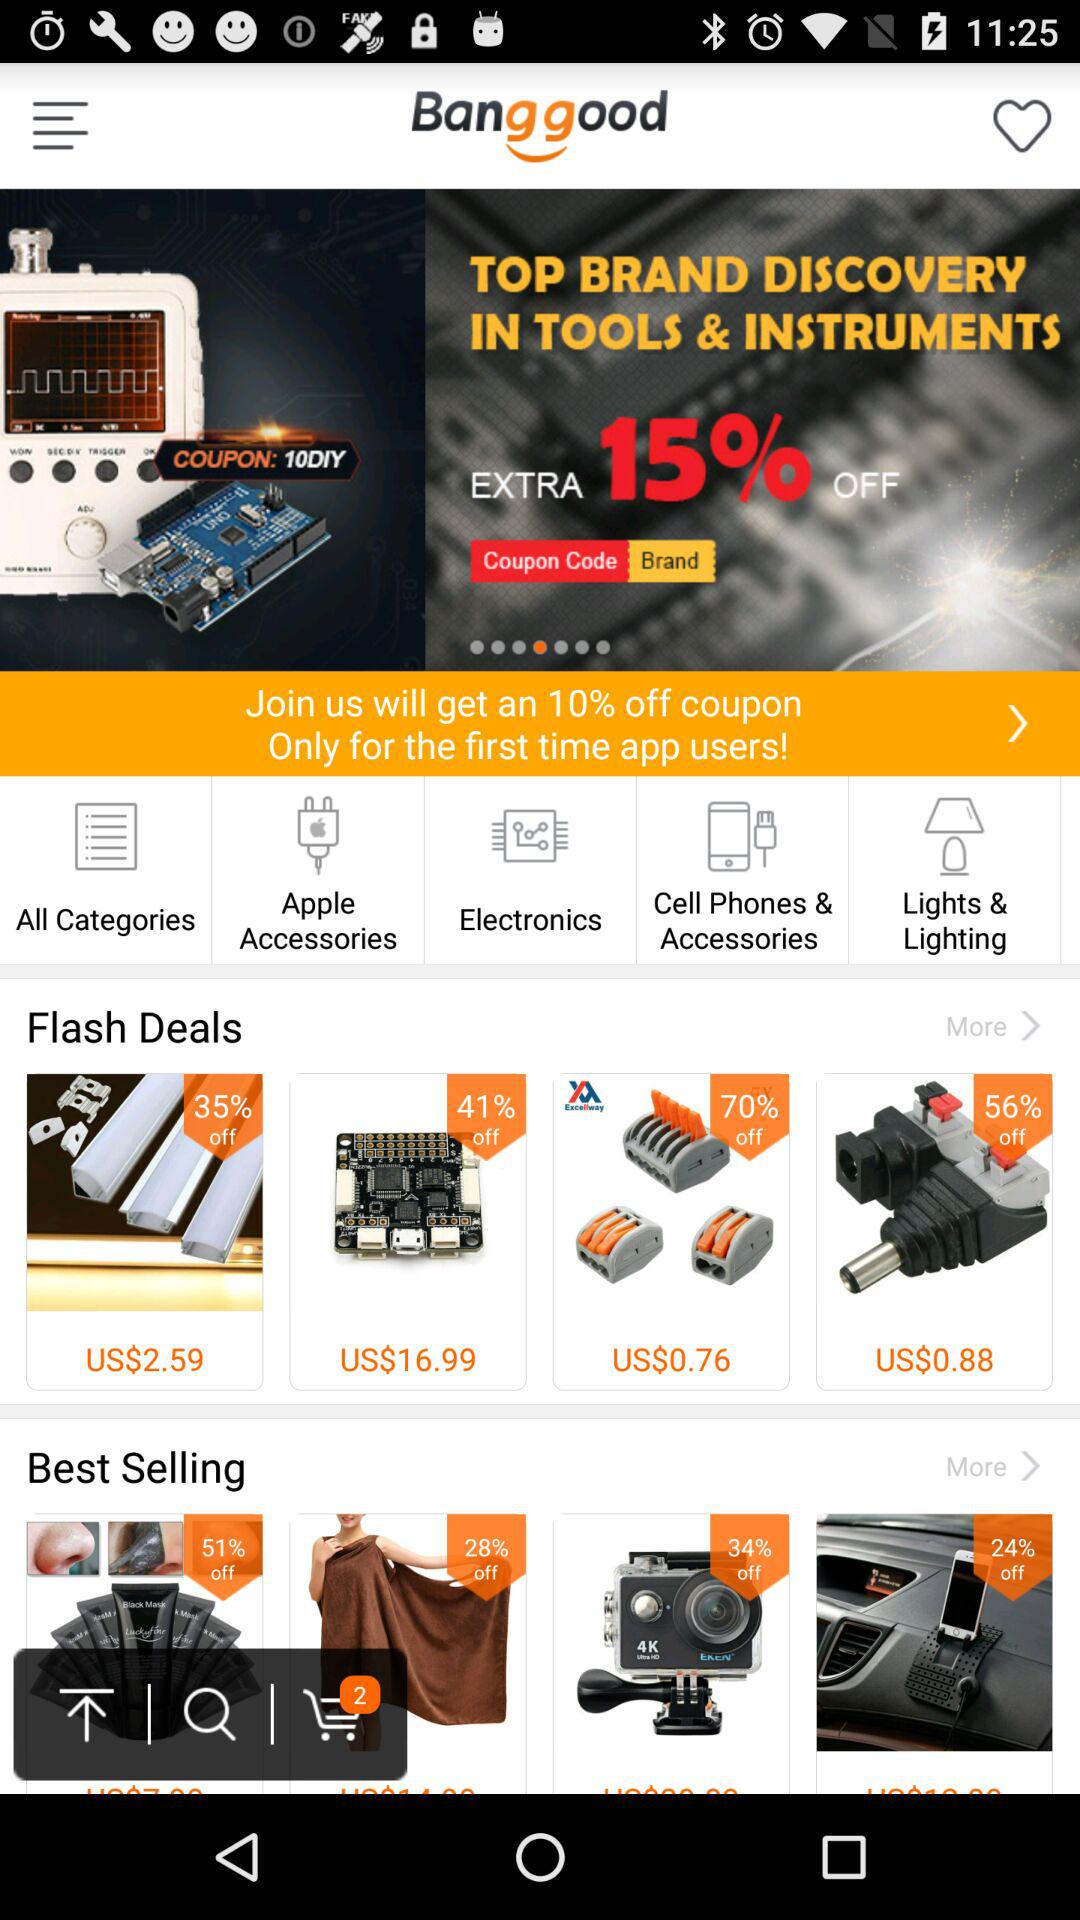How many items are in the cart? There are 2 items in the cart. 